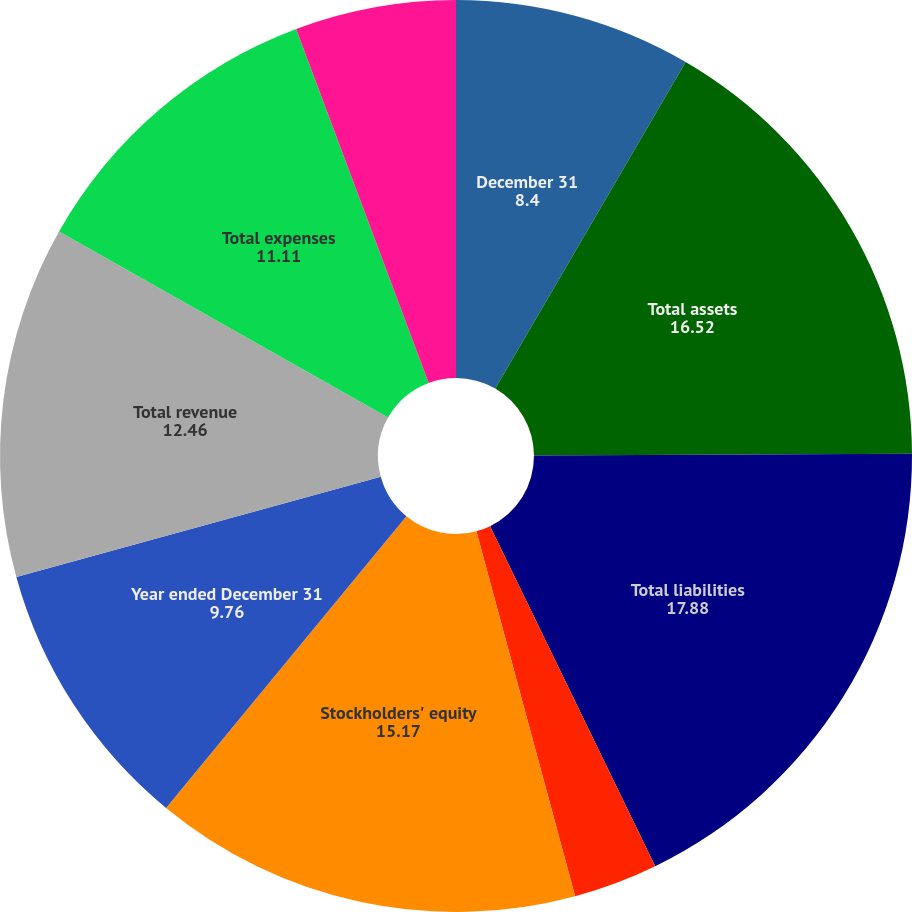Convert chart to OTSL. <chart><loc_0><loc_0><loc_500><loc_500><pie_chart><fcel>December 31<fcel>Total assets<fcel>Total liabilities<fcel>Non-controlling interest<fcel>Stockholders' equity<fcel>Year ended December 31<fcel>Total revenue<fcel>Total expenses<fcel>Operating income<nl><fcel>8.4%<fcel>16.52%<fcel>17.88%<fcel>2.99%<fcel>15.17%<fcel>9.76%<fcel>12.46%<fcel>11.11%<fcel>5.7%<nl></chart> 